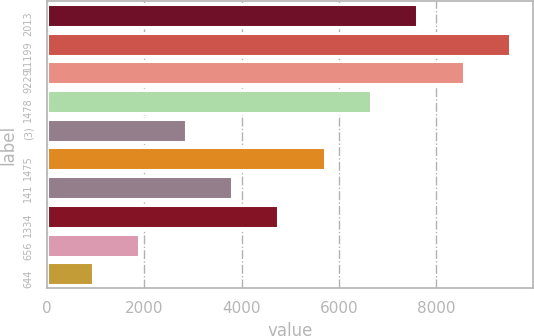Convert chart. <chart><loc_0><loc_0><loc_500><loc_500><bar_chart><fcel>2013<fcel>11199<fcel>9229<fcel>1478<fcel>(3)<fcel>1475<fcel>141<fcel>1334<fcel>656<fcel>644<nl><fcel>7609.75<fcel>9512.01<fcel>8560.88<fcel>6658.62<fcel>2854.1<fcel>5707.49<fcel>3805.23<fcel>4756.36<fcel>1902.97<fcel>951.84<nl></chart> 